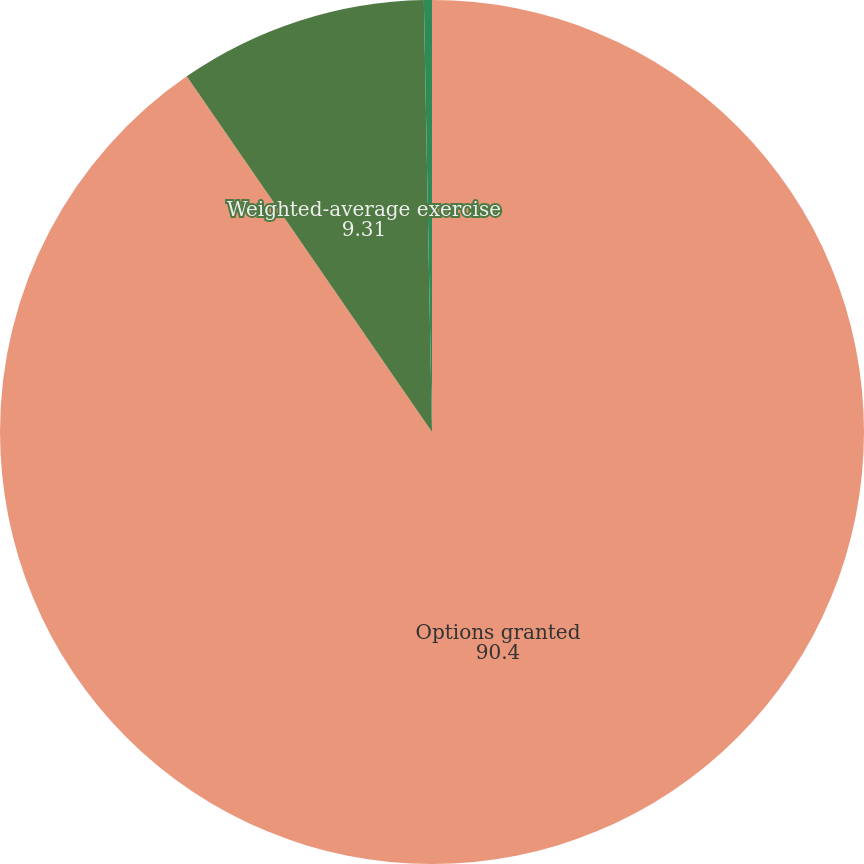<chart> <loc_0><loc_0><loc_500><loc_500><pie_chart><fcel>Options granted<fcel>Weighted-average exercise<fcel>Weighted-average grant date<nl><fcel>90.4%<fcel>9.31%<fcel>0.3%<nl></chart> 